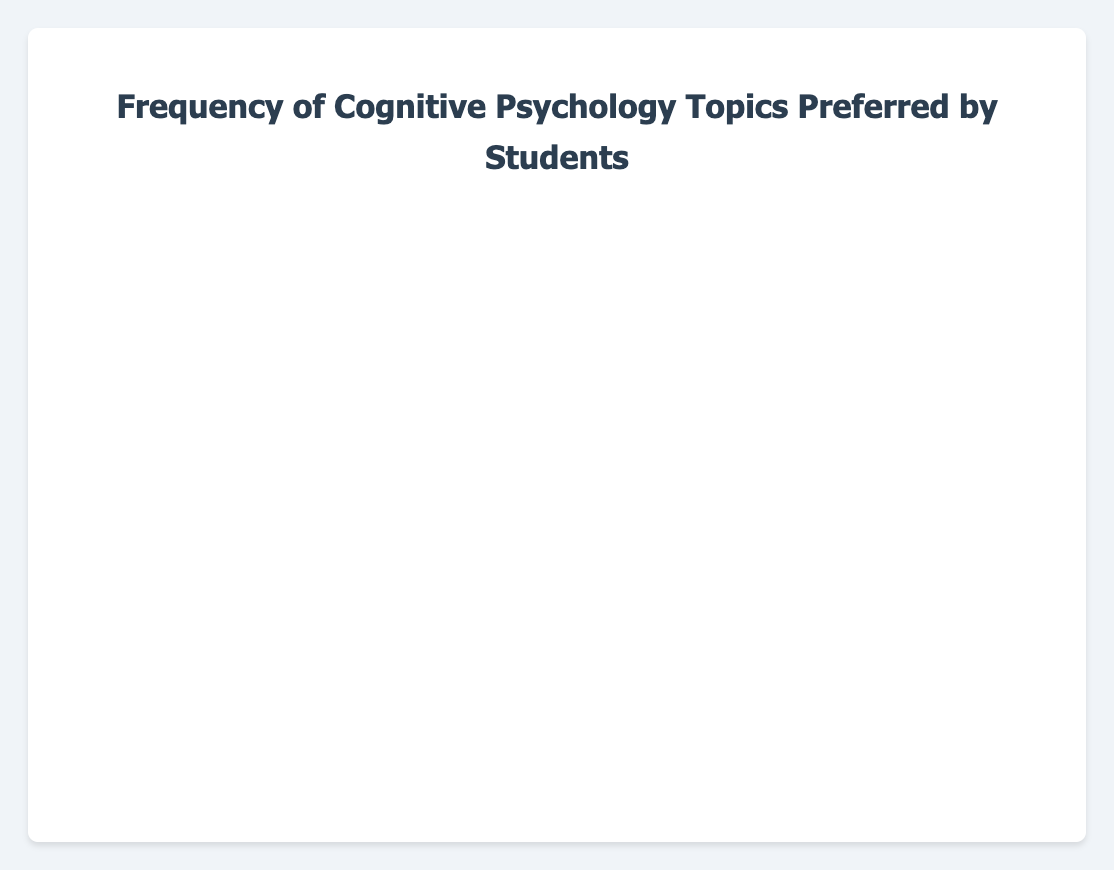Which topic has the highest frequency among students in the workshops? Locate the bar with the greatest length. The bar labeled "Memory" has the greatest length, indicating the highest frequency.
Answer: Memory What is the total frequency for the topics "Emotional Regulation" and "Creativity"? Sum the frequencies for "Emotional Regulation" (41) and "Creativity" (35). So, 41 + 35 = 76.
Answer: 76 How does the popularity of "Attention" compare to "Problem Solving"? Compare the frequency values for "Attention" (38) and "Problem Solving" (34). Since 38 > 34, "Attention" is more popular than "Problem Solving".
Answer: Attention is more popular Which topic has the lowest frequency among students? Locate the bar with the shortest length. The bar labeled "Cognitive Development" has the shortest length, indicating the lowest frequency.
Answer: Cognitive Development What is the average frequency of the top three most preferred topics? Identify the top three frequencies: Memory (45), Emotional Regulation (41), and Creativity (35). Sum these values: 45 + 41 + 35 = 121. Divide by 3 to find the average: 121 / 3 = 40.33.
Answer: 40.33 Is the frequency of "Decision Making" higher or lower than the frequency of "Neuroplasticity"? Compare the frequency values for "Decision Making" (29) and "Neuroplasticity" (28). Since 29 > 28, "Decision Making" has a higher frequency than "Neuroplasticity".
Answer: Higher What is the difference in frequency between the topics "Language Processing" and "Perception"? Subtract the frequency for "Language Processing" (26) from "Perception" (32). So, 32 - 26 = 6.
Answer: 6 Which topics have a frequency above 30? Identify all bars with lengths corresponding to frequencies over 30: "Memory" (45), "Attention" (38), "Problem Solving" (34), "Emotional Regulation" (41), "Perception" (32), and "Creativity" (35).
Answer: Memory, Attention, Problem Solving, Emotional Regulation, Perception, Creativity What is the combined frequency of topics related to problem-solving and critical thinking? Sum the frequencies for "Problem Solving" (34) and "Decision Making" (29). So, 34 + 29 = 63.
Answer: 63 Among "Attention," "Language Processing," and "Neuroplasticity," which has the median frequency? List the frequencies in ascending order: "Language Processing" (26), "Neuroplasticity" (28), "Attention" (38). The median value is the one in the middle, which is "Neuroplasticity" (28).
Answer: Neuroplasticity 